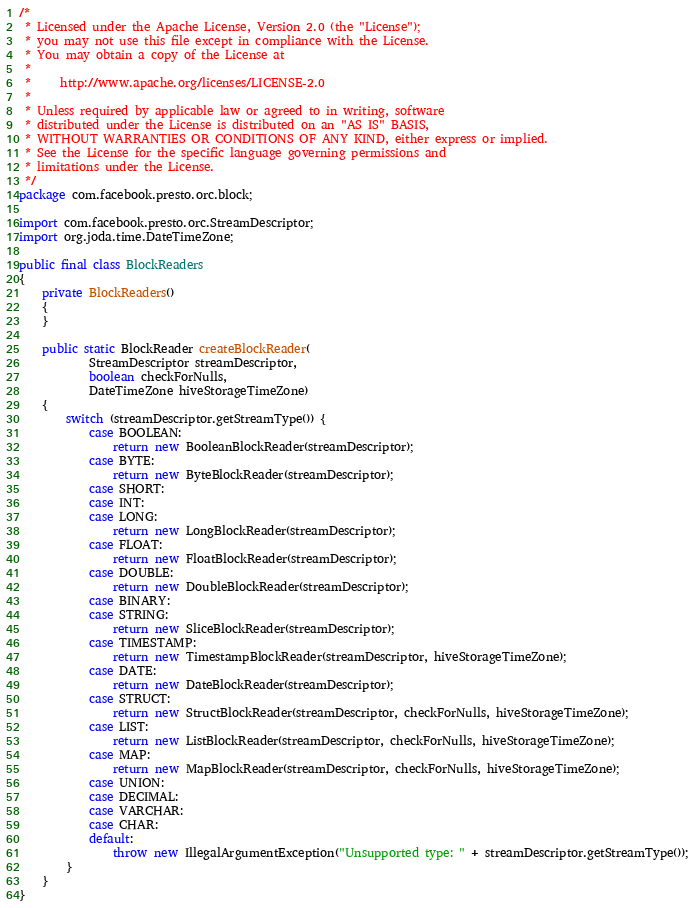Convert code to text. <code><loc_0><loc_0><loc_500><loc_500><_Java_>/*
 * Licensed under the Apache License, Version 2.0 (the "License");
 * you may not use this file except in compliance with the License.
 * You may obtain a copy of the License at
 *
 *     http://www.apache.org/licenses/LICENSE-2.0
 *
 * Unless required by applicable law or agreed to in writing, software
 * distributed under the License is distributed on an "AS IS" BASIS,
 * WITHOUT WARRANTIES OR CONDITIONS OF ANY KIND, either express or implied.
 * See the License for the specific language governing permissions and
 * limitations under the License.
 */
package com.facebook.presto.orc.block;

import com.facebook.presto.orc.StreamDescriptor;
import org.joda.time.DateTimeZone;

public final class BlockReaders
{
    private BlockReaders()
    {
    }

    public static BlockReader createBlockReader(
            StreamDescriptor streamDescriptor,
            boolean checkForNulls,
            DateTimeZone hiveStorageTimeZone)
    {
        switch (streamDescriptor.getStreamType()) {
            case BOOLEAN:
                return new BooleanBlockReader(streamDescriptor);
            case BYTE:
                return new ByteBlockReader(streamDescriptor);
            case SHORT:
            case INT:
            case LONG:
                return new LongBlockReader(streamDescriptor);
            case FLOAT:
                return new FloatBlockReader(streamDescriptor);
            case DOUBLE:
                return new DoubleBlockReader(streamDescriptor);
            case BINARY:
            case STRING:
                return new SliceBlockReader(streamDescriptor);
            case TIMESTAMP:
                return new TimestampBlockReader(streamDescriptor, hiveStorageTimeZone);
            case DATE:
                return new DateBlockReader(streamDescriptor);
            case STRUCT:
                return new StructBlockReader(streamDescriptor, checkForNulls, hiveStorageTimeZone);
            case LIST:
                return new ListBlockReader(streamDescriptor, checkForNulls, hiveStorageTimeZone);
            case MAP:
                return new MapBlockReader(streamDescriptor, checkForNulls, hiveStorageTimeZone);
            case UNION:
            case DECIMAL:
            case VARCHAR:
            case CHAR:
            default:
                throw new IllegalArgumentException("Unsupported type: " + streamDescriptor.getStreamType());
        }
    }
}
</code> 